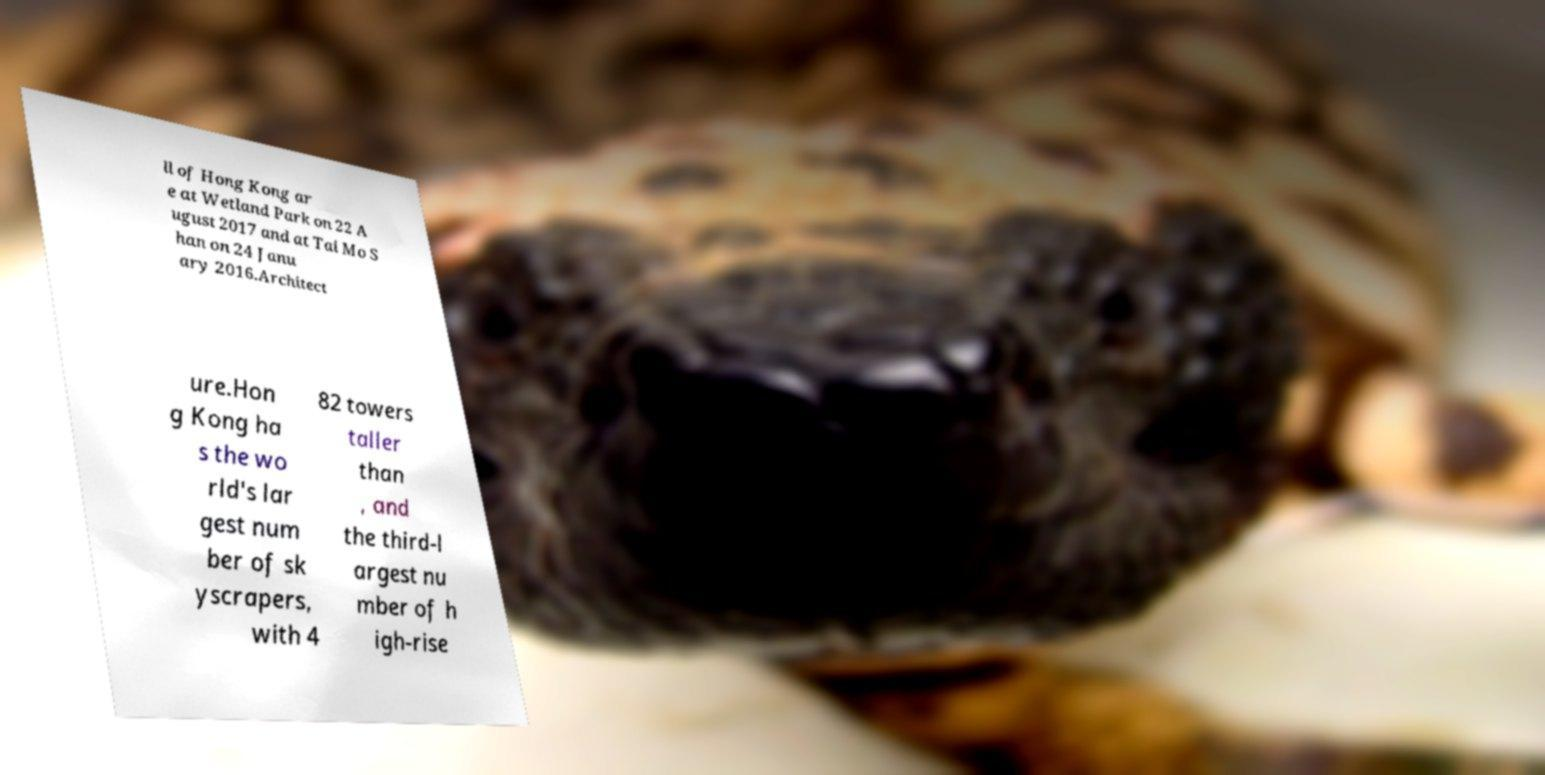For documentation purposes, I need the text within this image transcribed. Could you provide that? ll of Hong Kong ar e at Wetland Park on 22 A ugust 2017 and at Tai Mo S han on 24 Janu ary 2016.Architect ure.Hon g Kong ha s the wo rld's lar gest num ber of sk yscrapers, with 4 82 towers taller than , and the third-l argest nu mber of h igh-rise 